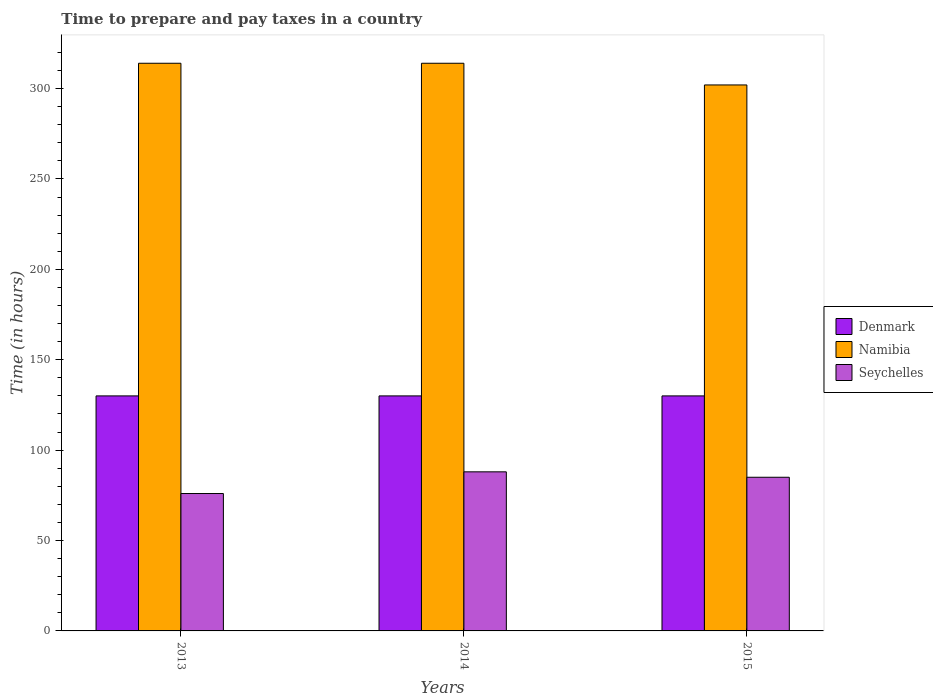How many different coloured bars are there?
Give a very brief answer. 3. Are the number of bars per tick equal to the number of legend labels?
Your answer should be very brief. Yes. What is the number of hours required to prepare and pay taxes in Namibia in 2014?
Provide a succinct answer. 314. Across all years, what is the maximum number of hours required to prepare and pay taxes in Denmark?
Offer a very short reply. 130. Across all years, what is the minimum number of hours required to prepare and pay taxes in Seychelles?
Provide a succinct answer. 76. In which year was the number of hours required to prepare and pay taxes in Namibia minimum?
Provide a short and direct response. 2015. What is the total number of hours required to prepare and pay taxes in Denmark in the graph?
Make the answer very short. 390. What is the difference between the number of hours required to prepare and pay taxes in Seychelles in 2014 and that in 2015?
Make the answer very short. 3. What is the difference between the number of hours required to prepare and pay taxes in Namibia in 2014 and the number of hours required to prepare and pay taxes in Denmark in 2013?
Give a very brief answer. 184. What is the average number of hours required to prepare and pay taxes in Denmark per year?
Offer a terse response. 130. In the year 2013, what is the difference between the number of hours required to prepare and pay taxes in Denmark and number of hours required to prepare and pay taxes in Seychelles?
Offer a very short reply. 54. In how many years, is the number of hours required to prepare and pay taxes in Namibia greater than 270 hours?
Ensure brevity in your answer.  3. What is the ratio of the number of hours required to prepare and pay taxes in Denmark in 2013 to that in 2014?
Offer a very short reply. 1. Is the number of hours required to prepare and pay taxes in Denmark in 2013 less than that in 2014?
Keep it short and to the point. No. What is the difference between the highest and the second highest number of hours required to prepare and pay taxes in Seychelles?
Keep it short and to the point. 3. What is the difference between the highest and the lowest number of hours required to prepare and pay taxes in Seychelles?
Offer a very short reply. 12. Is the sum of the number of hours required to prepare and pay taxes in Namibia in 2013 and 2014 greater than the maximum number of hours required to prepare and pay taxes in Denmark across all years?
Make the answer very short. Yes. What does the 3rd bar from the left in 2015 represents?
Provide a succinct answer. Seychelles. Is it the case that in every year, the sum of the number of hours required to prepare and pay taxes in Denmark and number of hours required to prepare and pay taxes in Seychelles is greater than the number of hours required to prepare and pay taxes in Namibia?
Ensure brevity in your answer.  No. How many bars are there?
Your answer should be compact. 9. How many years are there in the graph?
Provide a short and direct response. 3. Does the graph contain grids?
Ensure brevity in your answer.  No. Where does the legend appear in the graph?
Offer a terse response. Center right. How many legend labels are there?
Your answer should be compact. 3. How are the legend labels stacked?
Your response must be concise. Vertical. What is the title of the graph?
Ensure brevity in your answer.  Time to prepare and pay taxes in a country. Does "Norway" appear as one of the legend labels in the graph?
Provide a succinct answer. No. What is the label or title of the X-axis?
Offer a terse response. Years. What is the label or title of the Y-axis?
Provide a short and direct response. Time (in hours). What is the Time (in hours) of Denmark in 2013?
Give a very brief answer. 130. What is the Time (in hours) in Namibia in 2013?
Keep it short and to the point. 314. What is the Time (in hours) of Seychelles in 2013?
Give a very brief answer. 76. What is the Time (in hours) in Denmark in 2014?
Make the answer very short. 130. What is the Time (in hours) in Namibia in 2014?
Your answer should be very brief. 314. What is the Time (in hours) of Seychelles in 2014?
Offer a terse response. 88. What is the Time (in hours) in Denmark in 2015?
Ensure brevity in your answer.  130. What is the Time (in hours) of Namibia in 2015?
Ensure brevity in your answer.  302. Across all years, what is the maximum Time (in hours) of Denmark?
Provide a short and direct response. 130. Across all years, what is the maximum Time (in hours) in Namibia?
Your answer should be very brief. 314. Across all years, what is the maximum Time (in hours) in Seychelles?
Give a very brief answer. 88. Across all years, what is the minimum Time (in hours) in Denmark?
Your answer should be very brief. 130. Across all years, what is the minimum Time (in hours) of Namibia?
Your answer should be compact. 302. What is the total Time (in hours) of Denmark in the graph?
Your answer should be very brief. 390. What is the total Time (in hours) of Namibia in the graph?
Offer a very short reply. 930. What is the total Time (in hours) of Seychelles in the graph?
Make the answer very short. 249. What is the difference between the Time (in hours) in Namibia in 2013 and that in 2014?
Provide a short and direct response. 0. What is the difference between the Time (in hours) of Seychelles in 2013 and that in 2014?
Give a very brief answer. -12. What is the difference between the Time (in hours) in Denmark in 2013 and that in 2015?
Keep it short and to the point. 0. What is the difference between the Time (in hours) of Namibia in 2013 and that in 2015?
Ensure brevity in your answer.  12. What is the difference between the Time (in hours) of Namibia in 2014 and that in 2015?
Provide a succinct answer. 12. What is the difference between the Time (in hours) of Seychelles in 2014 and that in 2015?
Offer a very short reply. 3. What is the difference between the Time (in hours) in Denmark in 2013 and the Time (in hours) in Namibia in 2014?
Your response must be concise. -184. What is the difference between the Time (in hours) of Namibia in 2013 and the Time (in hours) of Seychelles in 2014?
Provide a short and direct response. 226. What is the difference between the Time (in hours) in Denmark in 2013 and the Time (in hours) in Namibia in 2015?
Provide a succinct answer. -172. What is the difference between the Time (in hours) in Denmark in 2013 and the Time (in hours) in Seychelles in 2015?
Your answer should be compact. 45. What is the difference between the Time (in hours) of Namibia in 2013 and the Time (in hours) of Seychelles in 2015?
Provide a short and direct response. 229. What is the difference between the Time (in hours) of Denmark in 2014 and the Time (in hours) of Namibia in 2015?
Provide a succinct answer. -172. What is the difference between the Time (in hours) of Denmark in 2014 and the Time (in hours) of Seychelles in 2015?
Ensure brevity in your answer.  45. What is the difference between the Time (in hours) of Namibia in 2014 and the Time (in hours) of Seychelles in 2015?
Your answer should be very brief. 229. What is the average Time (in hours) of Denmark per year?
Make the answer very short. 130. What is the average Time (in hours) in Namibia per year?
Your response must be concise. 310. In the year 2013, what is the difference between the Time (in hours) in Denmark and Time (in hours) in Namibia?
Keep it short and to the point. -184. In the year 2013, what is the difference between the Time (in hours) of Denmark and Time (in hours) of Seychelles?
Give a very brief answer. 54. In the year 2013, what is the difference between the Time (in hours) of Namibia and Time (in hours) of Seychelles?
Your answer should be very brief. 238. In the year 2014, what is the difference between the Time (in hours) in Denmark and Time (in hours) in Namibia?
Keep it short and to the point. -184. In the year 2014, what is the difference between the Time (in hours) of Denmark and Time (in hours) of Seychelles?
Make the answer very short. 42. In the year 2014, what is the difference between the Time (in hours) in Namibia and Time (in hours) in Seychelles?
Provide a succinct answer. 226. In the year 2015, what is the difference between the Time (in hours) in Denmark and Time (in hours) in Namibia?
Offer a terse response. -172. In the year 2015, what is the difference between the Time (in hours) of Namibia and Time (in hours) of Seychelles?
Your answer should be very brief. 217. What is the ratio of the Time (in hours) in Seychelles in 2013 to that in 2014?
Give a very brief answer. 0.86. What is the ratio of the Time (in hours) in Denmark in 2013 to that in 2015?
Your answer should be very brief. 1. What is the ratio of the Time (in hours) in Namibia in 2013 to that in 2015?
Keep it short and to the point. 1.04. What is the ratio of the Time (in hours) of Seychelles in 2013 to that in 2015?
Your answer should be very brief. 0.89. What is the ratio of the Time (in hours) in Namibia in 2014 to that in 2015?
Provide a short and direct response. 1.04. What is the ratio of the Time (in hours) in Seychelles in 2014 to that in 2015?
Your response must be concise. 1.04. What is the difference between the highest and the second highest Time (in hours) of Denmark?
Your response must be concise. 0. What is the difference between the highest and the second highest Time (in hours) of Namibia?
Give a very brief answer. 0. What is the difference between the highest and the lowest Time (in hours) in Namibia?
Your answer should be compact. 12. 